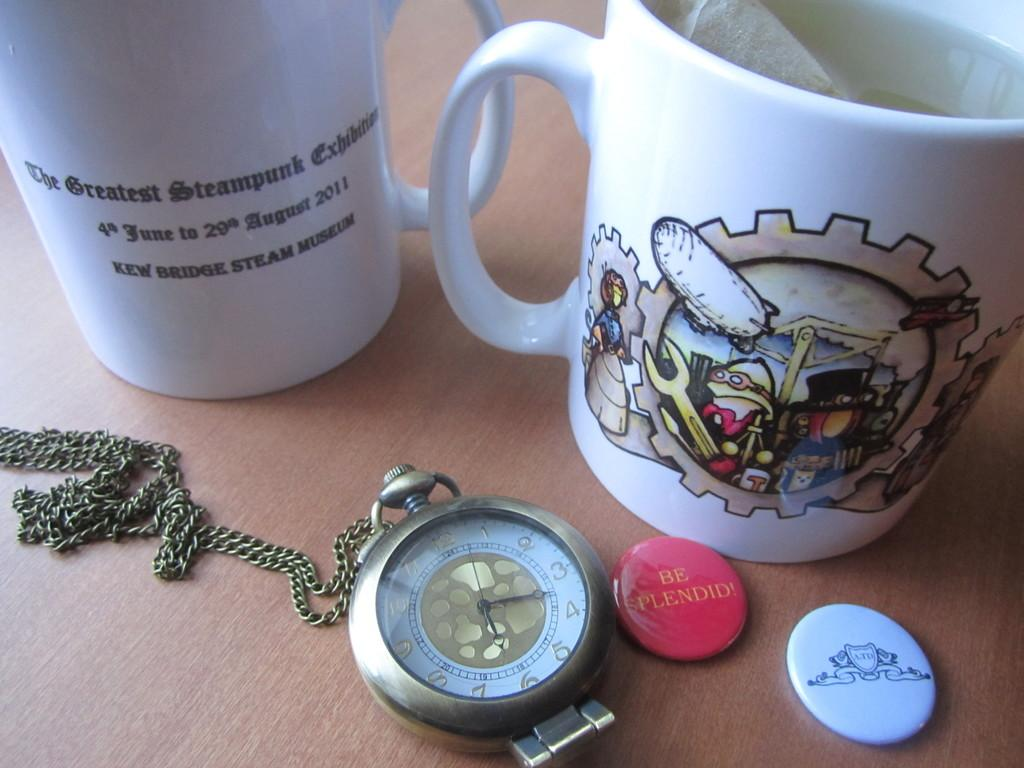<image>
Share a concise interpretation of the image provided. A mug is from the Kew Bridge Steam Museum. 